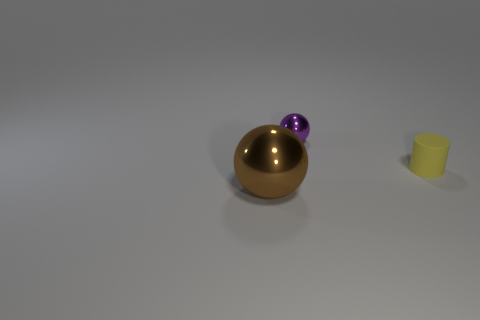Add 1 purple metallic things. How many objects exist? 4 Subtract all cylinders. How many objects are left? 2 Subtract 0 green cylinders. How many objects are left? 3 Subtract all tiny purple metal balls. Subtract all purple shiny objects. How many objects are left? 1 Add 1 purple metallic spheres. How many purple metallic spheres are left? 2 Add 3 purple metal things. How many purple metal things exist? 4 